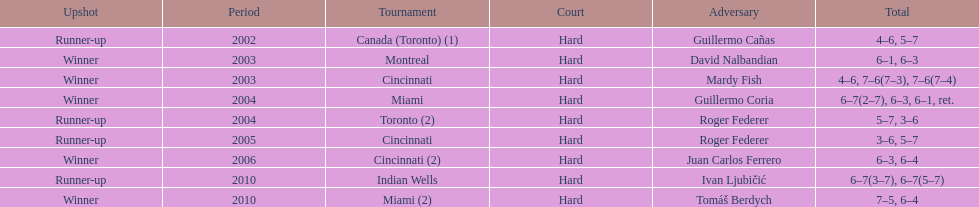How many times was the championship in miami? 2. 